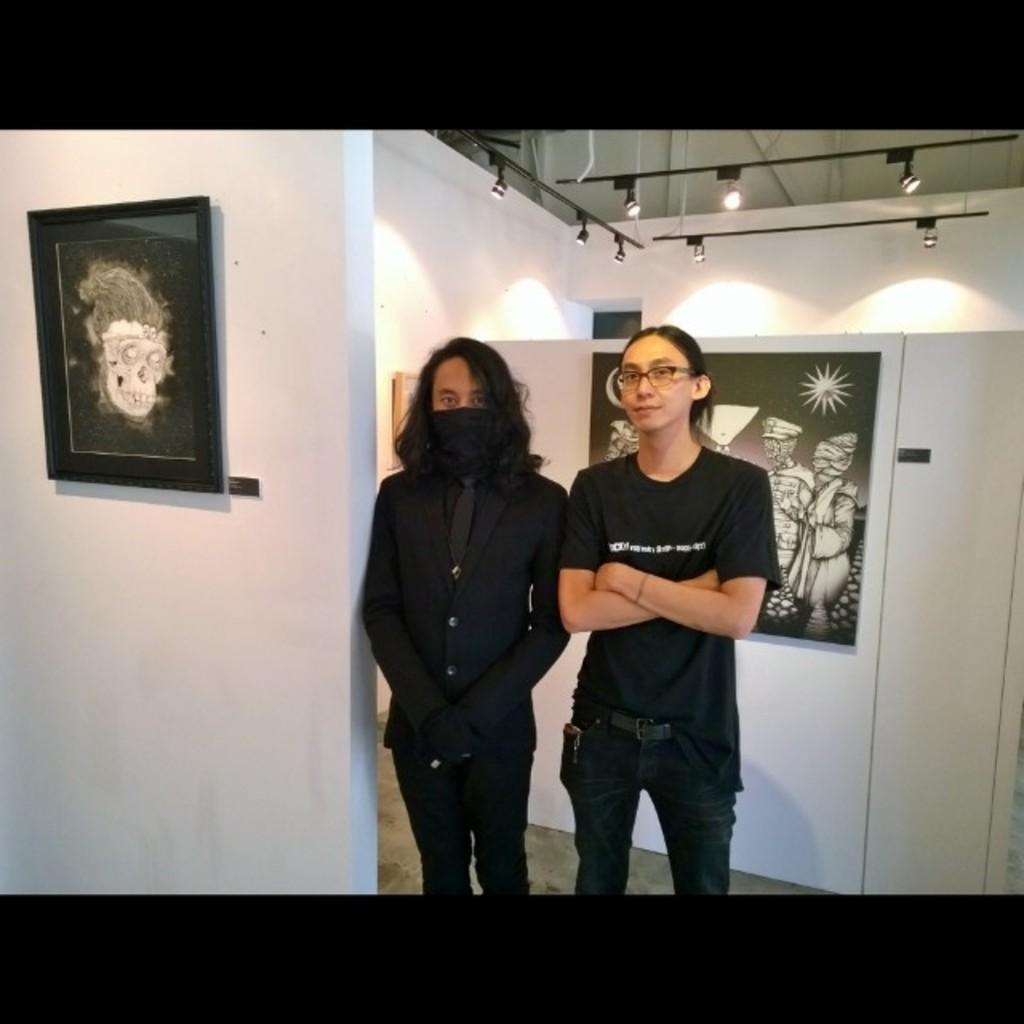Please provide a concise description of this image. In the picture there are two people, the first person is hiding the face under a mask and both of them are wearing black dress, there are two photos attached to a white background in that room and there are many lights to the roof. 